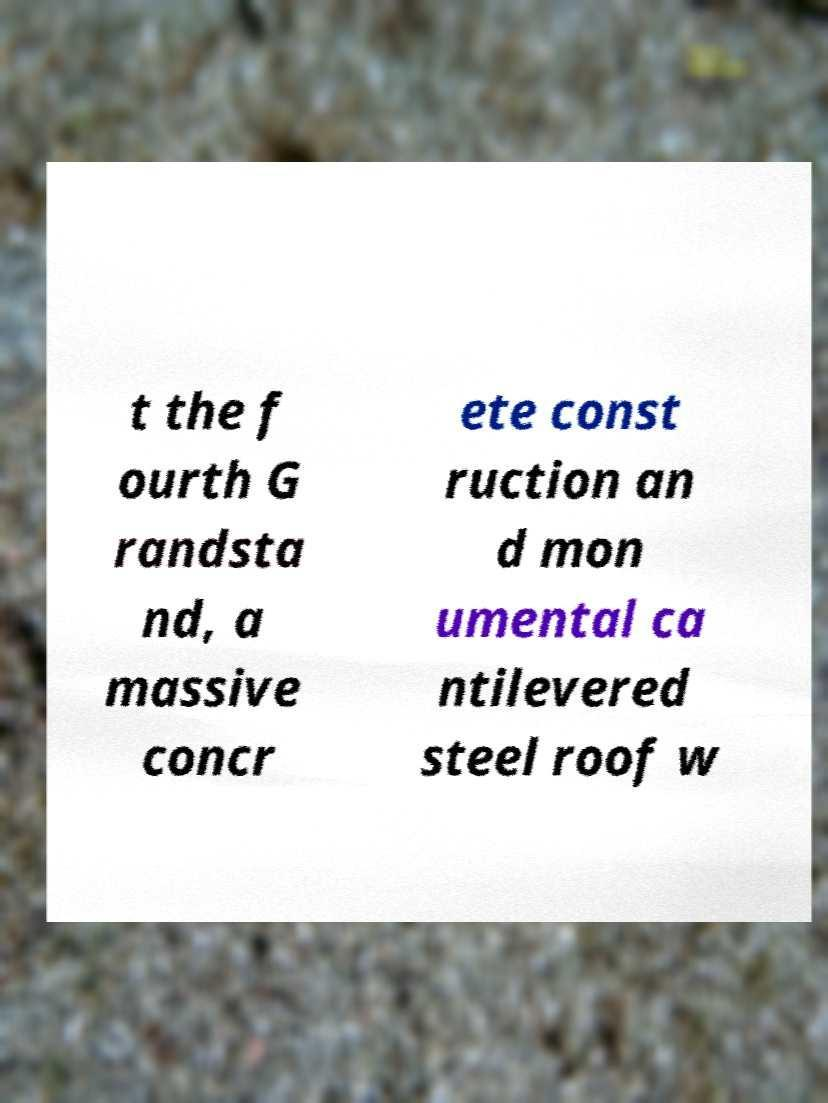Can you accurately transcribe the text from the provided image for me? t the f ourth G randsta nd, a massive concr ete const ruction an d mon umental ca ntilevered steel roof w 